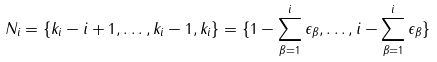<formula> <loc_0><loc_0><loc_500><loc_500>N _ { i } = \{ k _ { i } - i + 1 , \dots , k _ { i } - 1 , k _ { i } \} = \{ 1 - \sum _ { \beta = 1 } ^ { i } \epsilon _ { \beta } , \dots , i - \sum _ { \beta = 1 } ^ { i } \epsilon _ { \beta } \}</formula> 